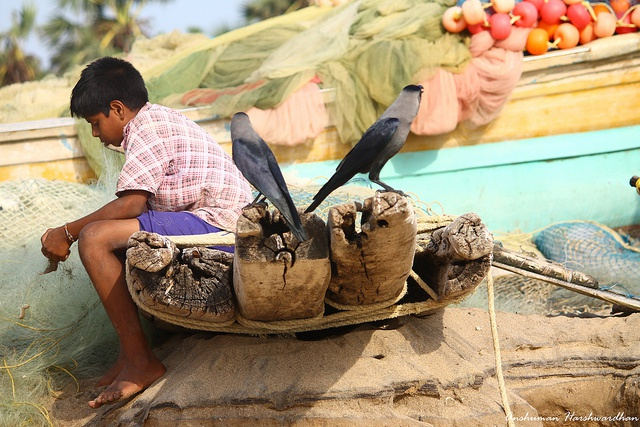Describe the objects in this image and their specific colors. I can see people in lavender, lightgray, maroon, black, and brown tones, boat in lavender, aquamarine, and turquoise tones, apple in lavender, tan, orange, salmon, and red tones, bird in lavender, black, darkgray, and gray tones, and bird in lavender, gray, darkgray, and black tones in this image. 